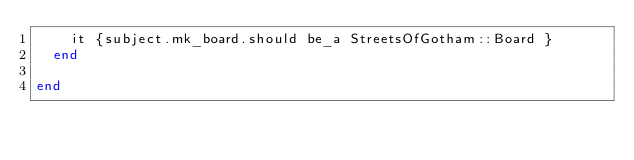<code> <loc_0><loc_0><loc_500><loc_500><_Ruby_>    it {subject.mk_board.should be_a StreetsOfGotham::Board }
  end

end
</code> 